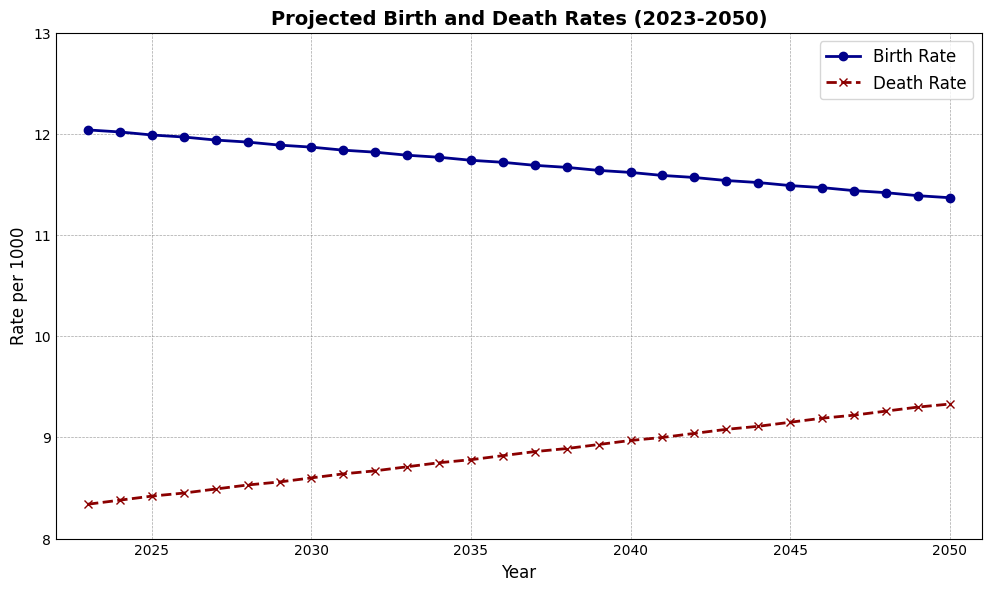What is the general trend for the birth rate from 2023 to 2050? The birth rate decreases over the years. By inspecting the curve for the birth rate, it shows a downward trajectory from 12.04 in 2023 to 11.37 in 2050.
Answer: The birth rate decreases What are the birth rate and death rate in the year 2035? By referring to the figure, find the points corresponding to the year 2035 on the birth rate and death rate curves. The birth rate is around 11.74, and the death rate is approximately 8.78.
Answer: Birth rate: 11.74, Death rate: 8.78 In which year do the birth rate and death rate intersect, if ever? Observing the plot, there is no year where the birth and death rates intersect. The birth rate remains higher than the death rate throughout the given period.
Answer: They do not intersect What is the difference between the birth rate and death rate in 2040? By looking at the corresponding points in 2040, the birth rate is 11.62 and the death rate is 8.97. The difference is calculated as 11.62 - 8.97.
Answer: 2.65 How much does the death rate increase from 2023 to 2050? The death rate in 2023 is 8.34, and in 2050 is 9.33. The increase is calculated by subtracting 8.34 from 9.33.
Answer: 0.99 Which rate, birth or death, has a steeper trend between 2023 and 2050? Comparing the slopes of both trends, the birth rate shows a gradual decrease, while the death rate shows a more noticeable increase. The death rate has a steeper trend.
Answer: Death rate What is the average birth rate over the entire period from 2023 to 2050? Sum all the birth rate values from 2023 to 2050 and divide by the number of years (28 years). The average is calculated as (12.04 + 12.02 + ... + 11.37)/28.
Answer: 11.75 When does the death rate first exceed 9.0? By inspecting the death rate curve and identifying the first point where it surpasses 9.0, this occurs in 2040.
Answer: 2040 What is the combined rate (birth rate + death rate) in 2030? For the year 2030, the birth rate is 11.87 and the death rate is 8.60. The combined rate is 11.87 + 8.60.
Answer: 20.47 Is there any year where the birth rate declines by more than 0.05 compared to the previous year? By inspecting the birth rate trend, the largest decline seen between consecutive years is 0.03, which occurs consistently. Thus, there is no year with a decline more than 0.05.
Answer: No 